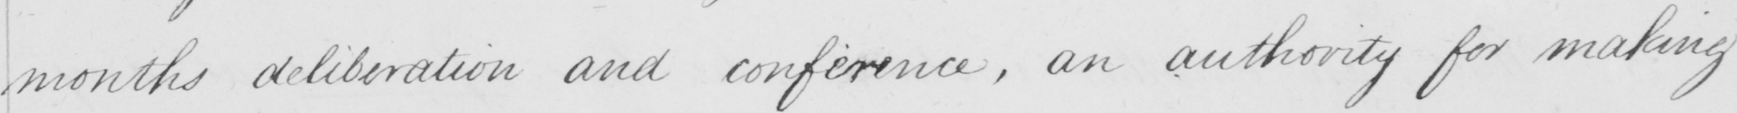Can you read and transcribe this handwriting? months deliberation and conference , an authority for making 